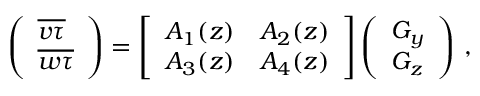Convert formula to latex. <formula><loc_0><loc_0><loc_500><loc_500>\begin{array} { r } { \left ( \begin{array} { l } { \overline { v \tau } } \\ { \overline { w \tau } } \end{array} \right ) = \left [ \begin{array} { l l } { A _ { 1 } ( z ) } & { A _ { 2 } ( z ) } \\ { A _ { 3 } ( z ) } & { A _ { 4 } ( z ) } \end{array} \right ] \left ( \begin{array} { l } { G _ { y } } \\ { G _ { z } } \end{array} \right ) \, , } \end{array}</formula> 